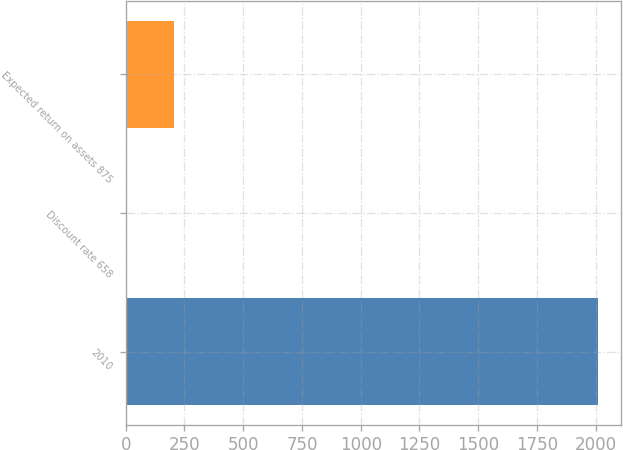Convert chart to OTSL. <chart><loc_0><loc_0><loc_500><loc_500><bar_chart><fcel>2010<fcel>Discount rate 658<fcel>Expected return on assets 875<nl><fcel>2008<fcel>5.57<fcel>205.81<nl></chart> 